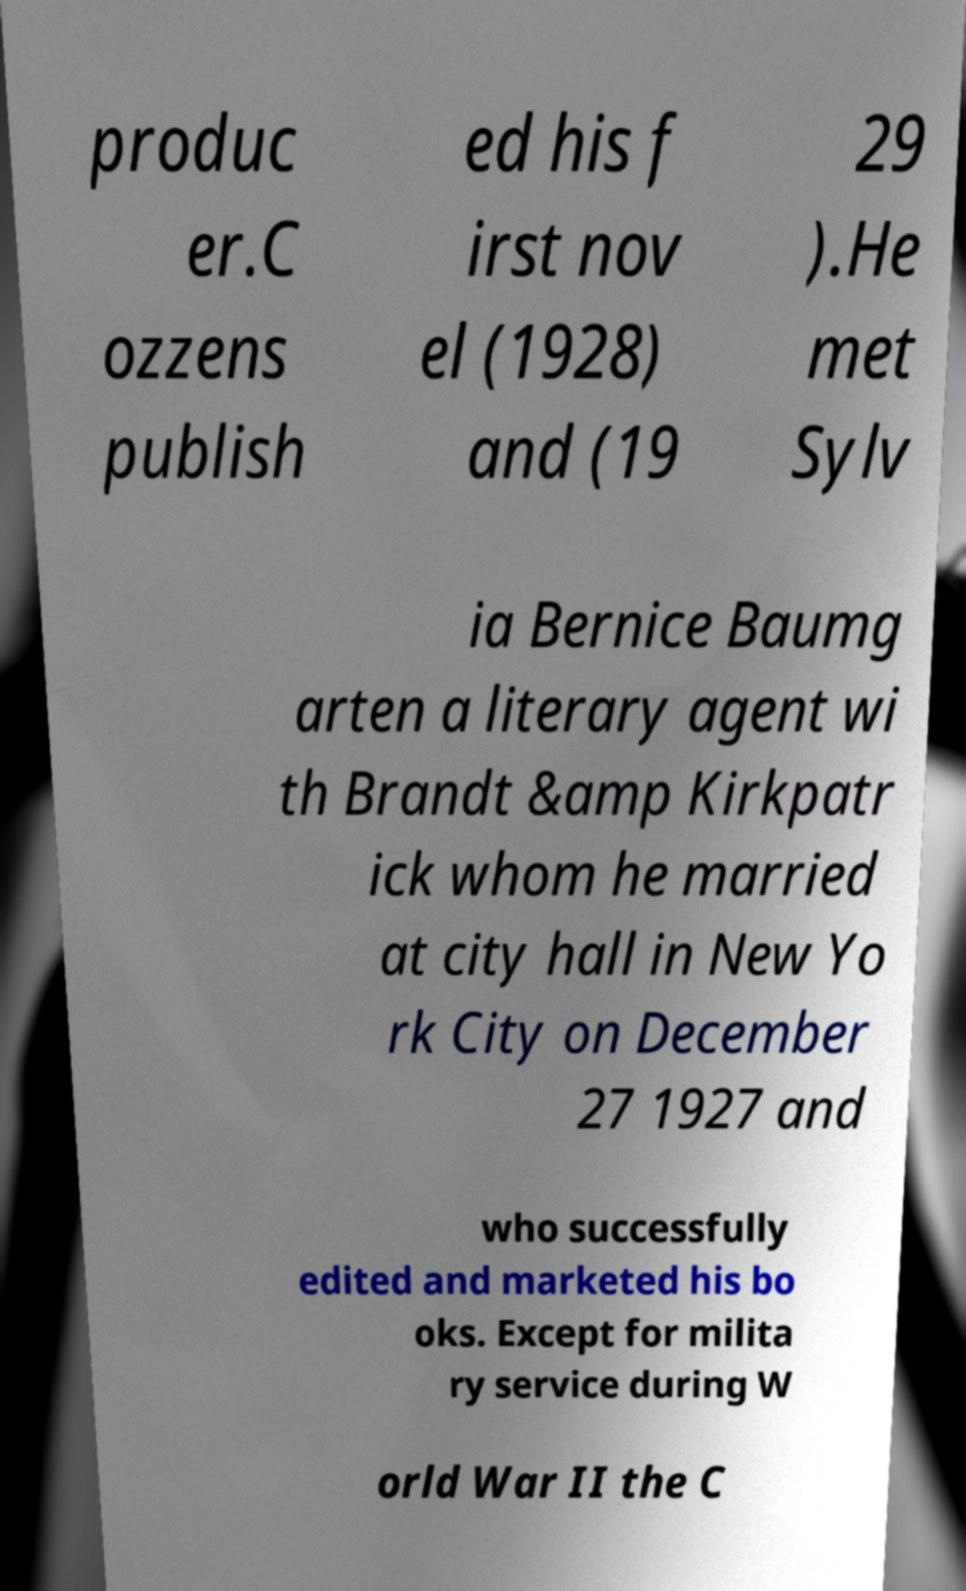What messages or text are displayed in this image? I need them in a readable, typed format. produc er.C ozzens publish ed his f irst nov el (1928) and (19 29 ).He met Sylv ia Bernice Baumg arten a literary agent wi th Brandt &amp Kirkpatr ick whom he married at city hall in New Yo rk City on December 27 1927 and who successfully edited and marketed his bo oks. Except for milita ry service during W orld War II the C 